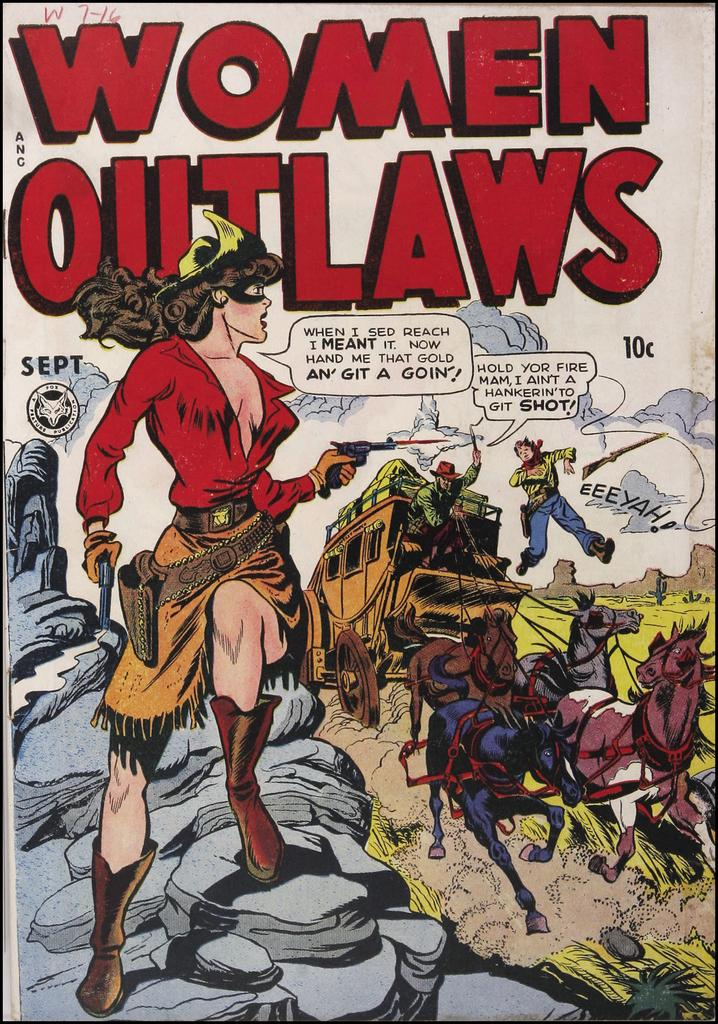<image>
Create a compact narrative representing the image presented. A comic book called Women Outlaws with a horse drawn carriage on the cover. 